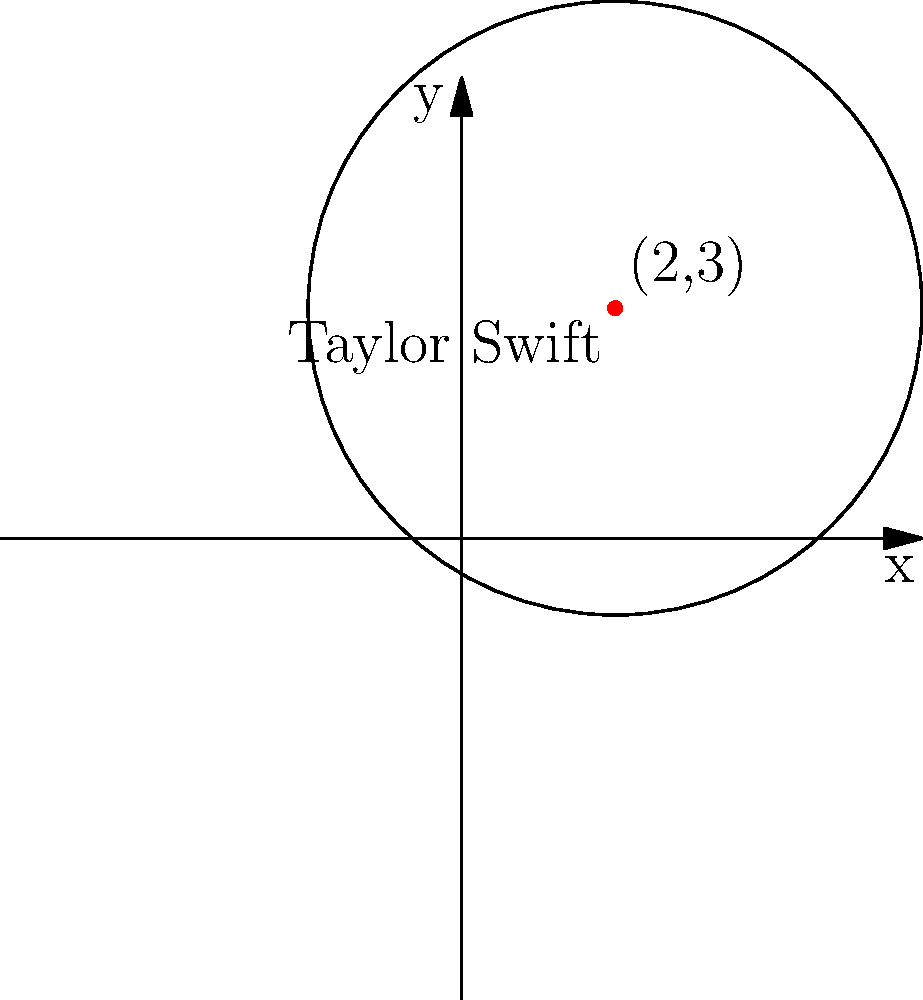Your college student has introduced you to Taylor Swift's music, and you've grown to appreciate her artistry. On a coordinate plane, Taylor Swift's position as a favorite artist is represented by the center of a circle at (2,3), and her popularity is represented by the radius of 4 units. What is the equation of this circle? Let's approach this step-by-step:

1) The general equation of a circle is $$(x-h)^2 + (y-k)^2 = r^2$$
   where $(h,k)$ is the center and $r$ is the radius.

2) In this case:
   - The center $(h,k)$ is $(2,3)$
   - The radius $r$ is 4

3) Substituting these values into the general equation:
   $$(x-2)^2 + (y-3)^2 = 4^2$$

4) Simplify the right side:
   $$(x-2)^2 + (y-3)^2 = 16$$

This is the equation of the circle representing Taylor Swift's position and popularity.
Answer: $(x-2)^2 + (y-3)^2 = 16$ 